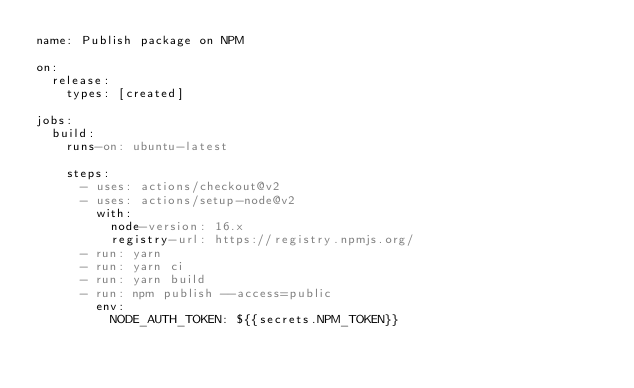<code> <loc_0><loc_0><loc_500><loc_500><_YAML_>name: Publish package on NPM

on:
  release:
    types: [created]

jobs:
  build:
    runs-on: ubuntu-latest

    steps:
      - uses: actions/checkout@v2
      - uses: actions/setup-node@v2
        with:
          node-version: 16.x
          registry-url: https://registry.npmjs.org/
      - run: yarn
      - run: yarn ci
      - run: yarn build
      - run: npm publish --access=public
        env:
          NODE_AUTH_TOKEN: ${{secrets.NPM_TOKEN}}
</code> 